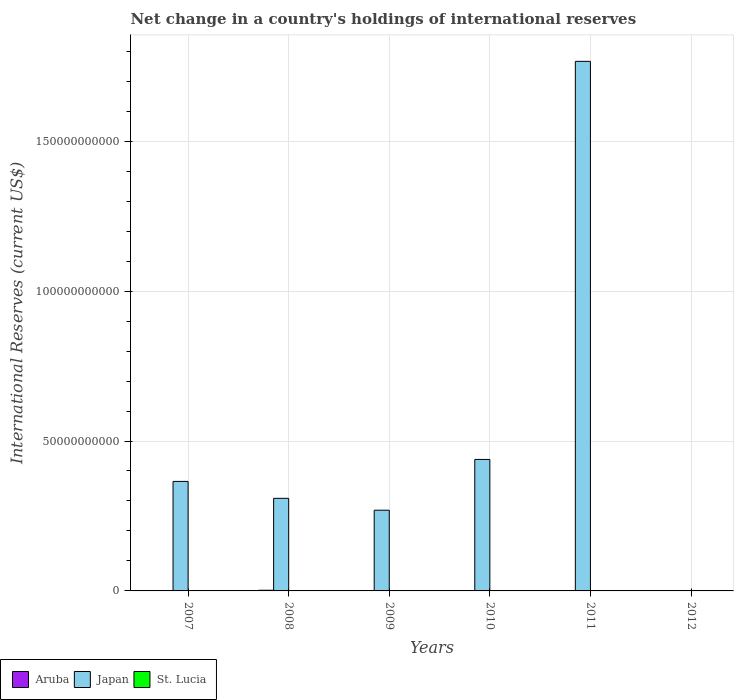Are the number of bars per tick equal to the number of legend labels?
Offer a very short reply. No. How many bars are there on the 3rd tick from the left?
Give a very brief answer. 3. How many bars are there on the 3rd tick from the right?
Offer a very short reply. 2. Across all years, what is the maximum international reserves in Aruba?
Your answer should be very brief. 2.25e+08. Across all years, what is the minimum international reserves in Japan?
Provide a succinct answer. 0. In which year was the international reserves in Japan maximum?
Make the answer very short. 2011. What is the total international reserves in Japan in the graph?
Your answer should be very brief. 3.15e+11. What is the difference between the international reserves in St. Lucia in 2007 and that in 2010?
Keep it short and to the point. -2.51e+06. What is the difference between the international reserves in Japan in 2007 and the international reserves in Aruba in 2012?
Ensure brevity in your answer.  3.65e+1. What is the average international reserves in Japan per year?
Make the answer very short. 5.25e+1. In the year 2010, what is the difference between the international reserves in St. Lucia and international reserves in Japan?
Give a very brief answer. -4.38e+1. What is the ratio of the international reserves in St. Lucia in 2007 to that in 2009?
Ensure brevity in your answer.  0.58. Is the difference between the international reserves in St. Lucia in 2007 and 2010 greater than the difference between the international reserves in Japan in 2007 and 2010?
Keep it short and to the point. Yes. What is the difference between the highest and the second highest international reserves in Japan?
Offer a very short reply. 1.33e+11. What is the difference between the highest and the lowest international reserves in Japan?
Offer a terse response. 1.77e+11. In how many years, is the international reserves in St. Lucia greater than the average international reserves in St. Lucia taken over all years?
Provide a short and direct response. 4. Is the sum of the international reserves in Japan in 2008 and 2010 greater than the maximum international reserves in Aruba across all years?
Offer a terse response. Yes. Is it the case that in every year, the sum of the international reserves in Japan and international reserves in St. Lucia is greater than the international reserves in Aruba?
Your answer should be compact. No. How many bars are there?
Provide a short and direct response. 13. What is the difference between two consecutive major ticks on the Y-axis?
Offer a very short reply. 5.00e+1. Are the values on the major ticks of Y-axis written in scientific E-notation?
Ensure brevity in your answer.  No. What is the title of the graph?
Make the answer very short. Net change in a country's holdings of international reserves. Does "Algeria" appear as one of the legend labels in the graph?
Your answer should be very brief. No. What is the label or title of the Y-axis?
Ensure brevity in your answer.  International Reserves (current US$). What is the International Reserves (current US$) of Aruba in 2007?
Your response must be concise. 4.32e+07. What is the International Reserves (current US$) in Japan in 2007?
Your answer should be compact. 3.65e+1. What is the International Reserves (current US$) in St. Lucia in 2007?
Keep it short and to the point. 1.86e+07. What is the International Reserves (current US$) of Aruba in 2008?
Make the answer very short. 2.25e+08. What is the International Reserves (current US$) of Japan in 2008?
Your answer should be compact. 3.09e+1. What is the International Reserves (current US$) in Aruba in 2009?
Provide a short and direct response. 3.42e+07. What is the International Reserves (current US$) of Japan in 2009?
Keep it short and to the point. 2.69e+1. What is the International Reserves (current US$) of St. Lucia in 2009?
Offer a terse response. 3.23e+07. What is the International Reserves (current US$) of Japan in 2010?
Ensure brevity in your answer.  4.39e+1. What is the International Reserves (current US$) in St. Lucia in 2010?
Your response must be concise. 2.11e+07. What is the International Reserves (current US$) of Japan in 2011?
Offer a very short reply. 1.77e+11. What is the International Reserves (current US$) of St. Lucia in 2011?
Provide a succinct answer. 0. What is the International Reserves (current US$) in Aruba in 2012?
Your answer should be compact. 6.63e+07. What is the International Reserves (current US$) of Japan in 2012?
Your answer should be compact. 0. What is the International Reserves (current US$) in St. Lucia in 2012?
Your answer should be compact. 1.65e+07. Across all years, what is the maximum International Reserves (current US$) in Aruba?
Offer a terse response. 2.25e+08. Across all years, what is the maximum International Reserves (current US$) in Japan?
Give a very brief answer. 1.77e+11. Across all years, what is the maximum International Reserves (current US$) of St. Lucia?
Provide a short and direct response. 3.23e+07. Across all years, what is the minimum International Reserves (current US$) of Aruba?
Offer a terse response. 0. Across all years, what is the minimum International Reserves (current US$) of St. Lucia?
Your response must be concise. 0. What is the total International Reserves (current US$) of Aruba in the graph?
Make the answer very short. 3.69e+08. What is the total International Reserves (current US$) in Japan in the graph?
Give a very brief answer. 3.15e+11. What is the total International Reserves (current US$) of St. Lucia in the graph?
Your response must be concise. 8.84e+07. What is the difference between the International Reserves (current US$) of Aruba in 2007 and that in 2008?
Your answer should be very brief. -1.82e+08. What is the difference between the International Reserves (current US$) of Japan in 2007 and that in 2008?
Offer a very short reply. 5.64e+09. What is the difference between the International Reserves (current US$) in Aruba in 2007 and that in 2009?
Give a very brief answer. 8.99e+06. What is the difference between the International Reserves (current US$) of Japan in 2007 and that in 2009?
Give a very brief answer. 9.60e+09. What is the difference between the International Reserves (current US$) in St. Lucia in 2007 and that in 2009?
Your response must be concise. -1.37e+07. What is the difference between the International Reserves (current US$) of Japan in 2007 and that in 2010?
Ensure brevity in your answer.  -7.33e+09. What is the difference between the International Reserves (current US$) in St. Lucia in 2007 and that in 2010?
Your answer should be very brief. -2.51e+06. What is the difference between the International Reserves (current US$) of Japan in 2007 and that in 2011?
Ensure brevity in your answer.  -1.40e+11. What is the difference between the International Reserves (current US$) in Aruba in 2007 and that in 2012?
Provide a short and direct response. -2.31e+07. What is the difference between the International Reserves (current US$) in St. Lucia in 2007 and that in 2012?
Offer a very short reply. 2.08e+06. What is the difference between the International Reserves (current US$) in Aruba in 2008 and that in 2009?
Your answer should be very brief. 1.91e+08. What is the difference between the International Reserves (current US$) in Japan in 2008 and that in 2009?
Make the answer very short. 3.96e+09. What is the difference between the International Reserves (current US$) in Japan in 2008 and that in 2010?
Your answer should be compact. -1.30e+1. What is the difference between the International Reserves (current US$) in Japan in 2008 and that in 2011?
Your answer should be very brief. -1.46e+11. What is the difference between the International Reserves (current US$) of Aruba in 2008 and that in 2012?
Provide a short and direct response. 1.59e+08. What is the difference between the International Reserves (current US$) in Japan in 2009 and that in 2010?
Your response must be concise. -1.69e+1. What is the difference between the International Reserves (current US$) in St. Lucia in 2009 and that in 2010?
Offer a terse response. 1.12e+07. What is the difference between the International Reserves (current US$) in Japan in 2009 and that in 2011?
Provide a short and direct response. -1.50e+11. What is the difference between the International Reserves (current US$) in Aruba in 2009 and that in 2012?
Provide a succinct answer. -3.21e+07. What is the difference between the International Reserves (current US$) of St. Lucia in 2009 and that in 2012?
Give a very brief answer. 1.58e+07. What is the difference between the International Reserves (current US$) of Japan in 2010 and that in 2011?
Your answer should be very brief. -1.33e+11. What is the difference between the International Reserves (current US$) of St. Lucia in 2010 and that in 2012?
Ensure brevity in your answer.  4.60e+06. What is the difference between the International Reserves (current US$) in Aruba in 2007 and the International Reserves (current US$) in Japan in 2008?
Provide a succinct answer. -3.08e+1. What is the difference between the International Reserves (current US$) of Aruba in 2007 and the International Reserves (current US$) of Japan in 2009?
Keep it short and to the point. -2.69e+1. What is the difference between the International Reserves (current US$) in Aruba in 2007 and the International Reserves (current US$) in St. Lucia in 2009?
Give a very brief answer. 1.09e+07. What is the difference between the International Reserves (current US$) in Japan in 2007 and the International Reserves (current US$) in St. Lucia in 2009?
Provide a short and direct response. 3.65e+1. What is the difference between the International Reserves (current US$) in Aruba in 2007 and the International Reserves (current US$) in Japan in 2010?
Make the answer very short. -4.38e+1. What is the difference between the International Reserves (current US$) in Aruba in 2007 and the International Reserves (current US$) in St. Lucia in 2010?
Your answer should be very brief. 2.21e+07. What is the difference between the International Reserves (current US$) in Japan in 2007 and the International Reserves (current US$) in St. Lucia in 2010?
Offer a very short reply. 3.65e+1. What is the difference between the International Reserves (current US$) in Aruba in 2007 and the International Reserves (current US$) in Japan in 2011?
Keep it short and to the point. -1.77e+11. What is the difference between the International Reserves (current US$) in Aruba in 2007 and the International Reserves (current US$) in St. Lucia in 2012?
Your answer should be compact. 2.67e+07. What is the difference between the International Reserves (current US$) of Japan in 2007 and the International Reserves (current US$) of St. Lucia in 2012?
Offer a very short reply. 3.65e+1. What is the difference between the International Reserves (current US$) in Aruba in 2008 and the International Reserves (current US$) in Japan in 2009?
Make the answer very short. -2.67e+1. What is the difference between the International Reserves (current US$) of Aruba in 2008 and the International Reserves (current US$) of St. Lucia in 2009?
Keep it short and to the point. 1.93e+08. What is the difference between the International Reserves (current US$) in Japan in 2008 and the International Reserves (current US$) in St. Lucia in 2009?
Provide a short and direct response. 3.08e+1. What is the difference between the International Reserves (current US$) in Aruba in 2008 and the International Reserves (current US$) in Japan in 2010?
Ensure brevity in your answer.  -4.36e+1. What is the difference between the International Reserves (current US$) of Aruba in 2008 and the International Reserves (current US$) of St. Lucia in 2010?
Provide a succinct answer. 2.04e+08. What is the difference between the International Reserves (current US$) of Japan in 2008 and the International Reserves (current US$) of St. Lucia in 2010?
Make the answer very short. 3.09e+1. What is the difference between the International Reserves (current US$) in Aruba in 2008 and the International Reserves (current US$) in Japan in 2011?
Your response must be concise. -1.76e+11. What is the difference between the International Reserves (current US$) of Aruba in 2008 and the International Reserves (current US$) of St. Lucia in 2012?
Provide a succinct answer. 2.09e+08. What is the difference between the International Reserves (current US$) of Japan in 2008 and the International Reserves (current US$) of St. Lucia in 2012?
Your answer should be very brief. 3.09e+1. What is the difference between the International Reserves (current US$) of Aruba in 2009 and the International Reserves (current US$) of Japan in 2010?
Keep it short and to the point. -4.38e+1. What is the difference between the International Reserves (current US$) in Aruba in 2009 and the International Reserves (current US$) in St. Lucia in 2010?
Ensure brevity in your answer.  1.31e+07. What is the difference between the International Reserves (current US$) of Japan in 2009 and the International Reserves (current US$) of St. Lucia in 2010?
Offer a very short reply. 2.69e+1. What is the difference between the International Reserves (current US$) of Aruba in 2009 and the International Reserves (current US$) of Japan in 2011?
Offer a terse response. -1.77e+11. What is the difference between the International Reserves (current US$) in Aruba in 2009 and the International Reserves (current US$) in St. Lucia in 2012?
Ensure brevity in your answer.  1.77e+07. What is the difference between the International Reserves (current US$) of Japan in 2009 and the International Reserves (current US$) of St. Lucia in 2012?
Offer a very short reply. 2.69e+1. What is the difference between the International Reserves (current US$) in Japan in 2010 and the International Reserves (current US$) in St. Lucia in 2012?
Give a very brief answer. 4.38e+1. What is the difference between the International Reserves (current US$) of Japan in 2011 and the International Reserves (current US$) of St. Lucia in 2012?
Your answer should be compact. 1.77e+11. What is the average International Reserves (current US$) of Aruba per year?
Offer a terse response. 6.15e+07. What is the average International Reserves (current US$) of Japan per year?
Make the answer very short. 5.25e+1. What is the average International Reserves (current US$) of St. Lucia per year?
Offer a terse response. 1.47e+07. In the year 2007, what is the difference between the International Reserves (current US$) in Aruba and International Reserves (current US$) in Japan?
Provide a short and direct response. -3.65e+1. In the year 2007, what is the difference between the International Reserves (current US$) in Aruba and International Reserves (current US$) in St. Lucia?
Make the answer very short. 2.46e+07. In the year 2007, what is the difference between the International Reserves (current US$) in Japan and International Reserves (current US$) in St. Lucia?
Ensure brevity in your answer.  3.65e+1. In the year 2008, what is the difference between the International Reserves (current US$) in Aruba and International Reserves (current US$) in Japan?
Ensure brevity in your answer.  -3.07e+1. In the year 2009, what is the difference between the International Reserves (current US$) in Aruba and International Reserves (current US$) in Japan?
Ensure brevity in your answer.  -2.69e+1. In the year 2009, what is the difference between the International Reserves (current US$) in Aruba and International Reserves (current US$) in St. Lucia?
Your answer should be very brief. 1.94e+06. In the year 2009, what is the difference between the International Reserves (current US$) in Japan and International Reserves (current US$) in St. Lucia?
Provide a succinct answer. 2.69e+1. In the year 2010, what is the difference between the International Reserves (current US$) of Japan and International Reserves (current US$) of St. Lucia?
Provide a short and direct response. 4.38e+1. In the year 2012, what is the difference between the International Reserves (current US$) of Aruba and International Reserves (current US$) of St. Lucia?
Offer a terse response. 4.98e+07. What is the ratio of the International Reserves (current US$) in Aruba in 2007 to that in 2008?
Ensure brevity in your answer.  0.19. What is the ratio of the International Reserves (current US$) of Japan in 2007 to that in 2008?
Give a very brief answer. 1.18. What is the ratio of the International Reserves (current US$) of Aruba in 2007 to that in 2009?
Offer a terse response. 1.26. What is the ratio of the International Reserves (current US$) of Japan in 2007 to that in 2009?
Your answer should be compact. 1.36. What is the ratio of the International Reserves (current US$) of St. Lucia in 2007 to that in 2009?
Offer a very short reply. 0.58. What is the ratio of the International Reserves (current US$) in Japan in 2007 to that in 2010?
Offer a terse response. 0.83. What is the ratio of the International Reserves (current US$) in St. Lucia in 2007 to that in 2010?
Provide a succinct answer. 0.88. What is the ratio of the International Reserves (current US$) of Japan in 2007 to that in 2011?
Ensure brevity in your answer.  0.21. What is the ratio of the International Reserves (current US$) in Aruba in 2007 to that in 2012?
Offer a terse response. 0.65. What is the ratio of the International Reserves (current US$) in St. Lucia in 2007 to that in 2012?
Provide a short and direct response. 1.13. What is the ratio of the International Reserves (current US$) in Aruba in 2008 to that in 2009?
Make the answer very short. 6.59. What is the ratio of the International Reserves (current US$) of Japan in 2008 to that in 2009?
Provide a short and direct response. 1.15. What is the ratio of the International Reserves (current US$) of Japan in 2008 to that in 2010?
Your answer should be very brief. 0.7. What is the ratio of the International Reserves (current US$) of Japan in 2008 to that in 2011?
Your answer should be very brief. 0.17. What is the ratio of the International Reserves (current US$) in Aruba in 2008 to that in 2012?
Provide a succinct answer. 3.4. What is the ratio of the International Reserves (current US$) in Japan in 2009 to that in 2010?
Keep it short and to the point. 0.61. What is the ratio of the International Reserves (current US$) of St. Lucia in 2009 to that in 2010?
Your response must be concise. 1.53. What is the ratio of the International Reserves (current US$) of Japan in 2009 to that in 2011?
Offer a very short reply. 0.15. What is the ratio of the International Reserves (current US$) in Aruba in 2009 to that in 2012?
Provide a short and direct response. 0.52. What is the ratio of the International Reserves (current US$) of St. Lucia in 2009 to that in 2012?
Provide a succinct answer. 1.96. What is the ratio of the International Reserves (current US$) in Japan in 2010 to that in 2011?
Provide a short and direct response. 0.25. What is the ratio of the International Reserves (current US$) in St. Lucia in 2010 to that in 2012?
Your answer should be compact. 1.28. What is the difference between the highest and the second highest International Reserves (current US$) of Aruba?
Give a very brief answer. 1.59e+08. What is the difference between the highest and the second highest International Reserves (current US$) of Japan?
Make the answer very short. 1.33e+11. What is the difference between the highest and the second highest International Reserves (current US$) in St. Lucia?
Offer a very short reply. 1.12e+07. What is the difference between the highest and the lowest International Reserves (current US$) of Aruba?
Your answer should be compact. 2.25e+08. What is the difference between the highest and the lowest International Reserves (current US$) in Japan?
Offer a very short reply. 1.77e+11. What is the difference between the highest and the lowest International Reserves (current US$) of St. Lucia?
Give a very brief answer. 3.23e+07. 